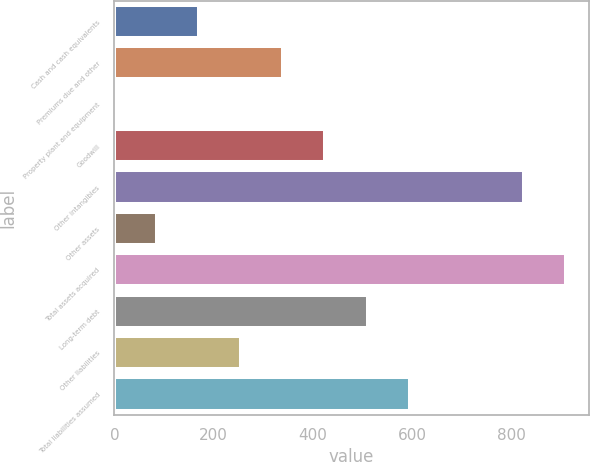Convert chart to OTSL. <chart><loc_0><loc_0><loc_500><loc_500><bar_chart><fcel>Cash and cash equivalents<fcel>Premiums due and other<fcel>Property plant and equipment<fcel>Goodwill<fcel>Other intangibles<fcel>Other assets<fcel>Total assets acquired<fcel>Long-term debt<fcel>Other liabilities<fcel>Total liabilities assumed<nl><fcel>170.44<fcel>340.48<fcel>0.4<fcel>425.5<fcel>826.12<fcel>85.42<fcel>911.14<fcel>510.52<fcel>255.46<fcel>595.54<nl></chart> 